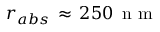Convert formula to latex. <formula><loc_0><loc_0><loc_500><loc_500>r _ { a b s } \, \approx \, 2 5 0 \, n m</formula> 